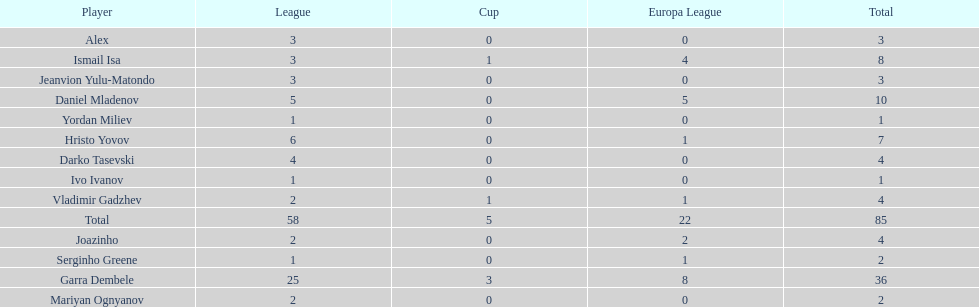What is the difference between vladimir gadzhev and yordan miliev's scores? 3. 